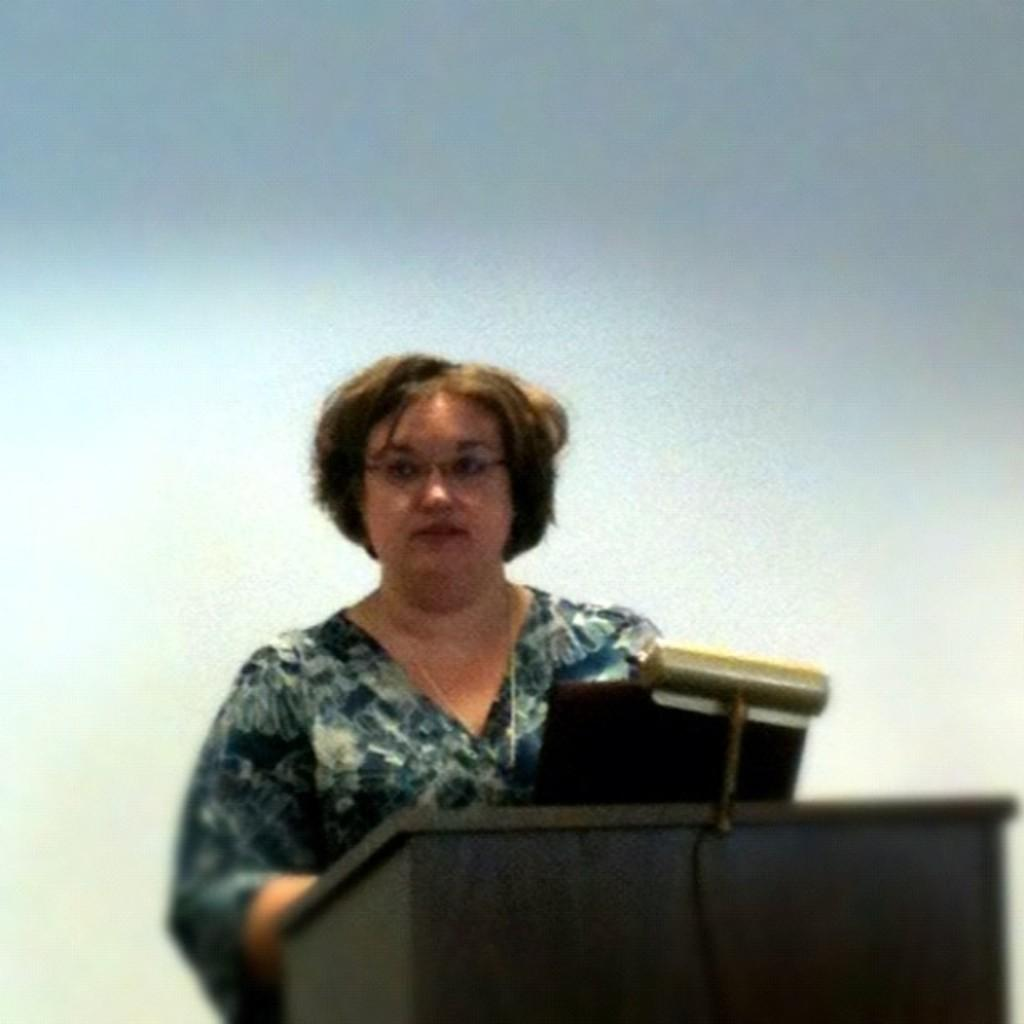What is the main object on the podium in the image? There is a laptop on the podium in the image. Who is standing behind the podium? A woman is standing behind the podium. What might the woman be using the laptop for? The laptop could be used for presenting information or giving a speech. Can you describe the background of the image? The background of the image is blurred. Is there an airplane visible in the image? No, there is no airplane present in the image. What type of pleasure can be seen being derived from the laptop in the image? There is no indication of pleasure in the image; it simply shows a woman standing behind a podium with a laptop. 